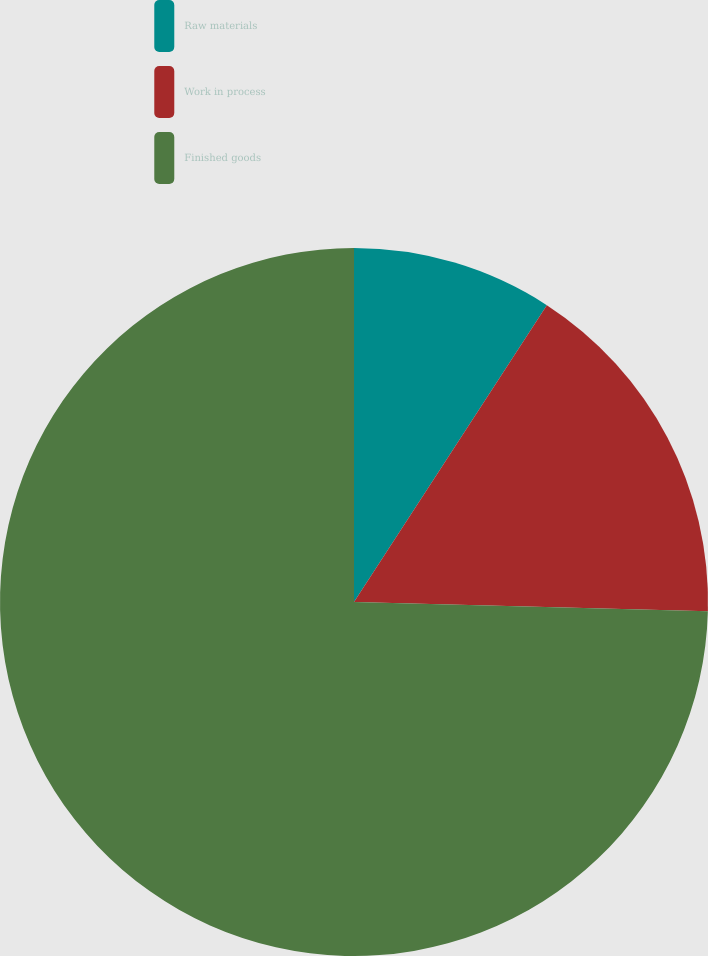Convert chart. <chart><loc_0><loc_0><loc_500><loc_500><pie_chart><fcel>Raw materials<fcel>Work in process<fcel>Finished goods<nl><fcel>9.17%<fcel>16.25%<fcel>74.59%<nl></chart> 